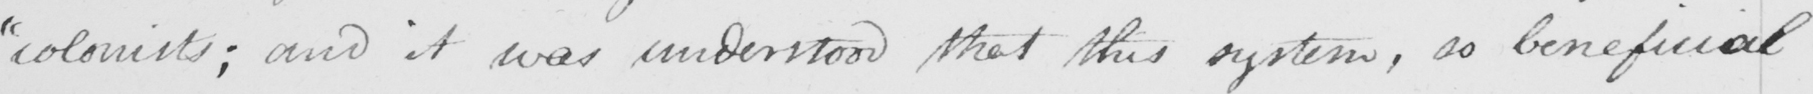Transcribe the text shown in this historical manuscript line. " colonists ; and it was understood that this system , so beneficial 